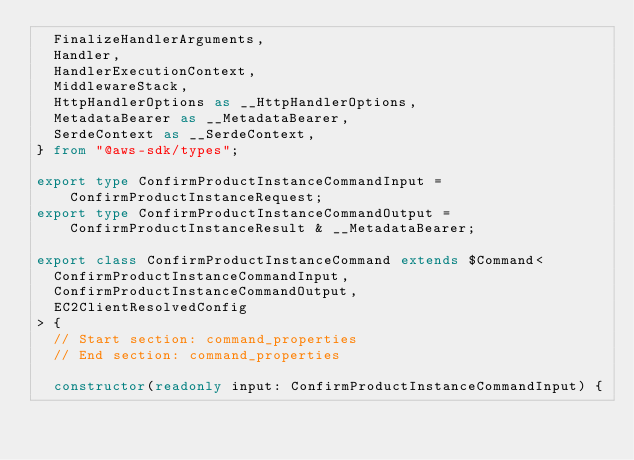Convert code to text. <code><loc_0><loc_0><loc_500><loc_500><_TypeScript_>  FinalizeHandlerArguments,
  Handler,
  HandlerExecutionContext,
  MiddlewareStack,
  HttpHandlerOptions as __HttpHandlerOptions,
  MetadataBearer as __MetadataBearer,
  SerdeContext as __SerdeContext,
} from "@aws-sdk/types";

export type ConfirmProductInstanceCommandInput = ConfirmProductInstanceRequest;
export type ConfirmProductInstanceCommandOutput = ConfirmProductInstanceResult & __MetadataBearer;

export class ConfirmProductInstanceCommand extends $Command<
  ConfirmProductInstanceCommandInput,
  ConfirmProductInstanceCommandOutput,
  EC2ClientResolvedConfig
> {
  // Start section: command_properties
  // End section: command_properties

  constructor(readonly input: ConfirmProductInstanceCommandInput) {</code> 